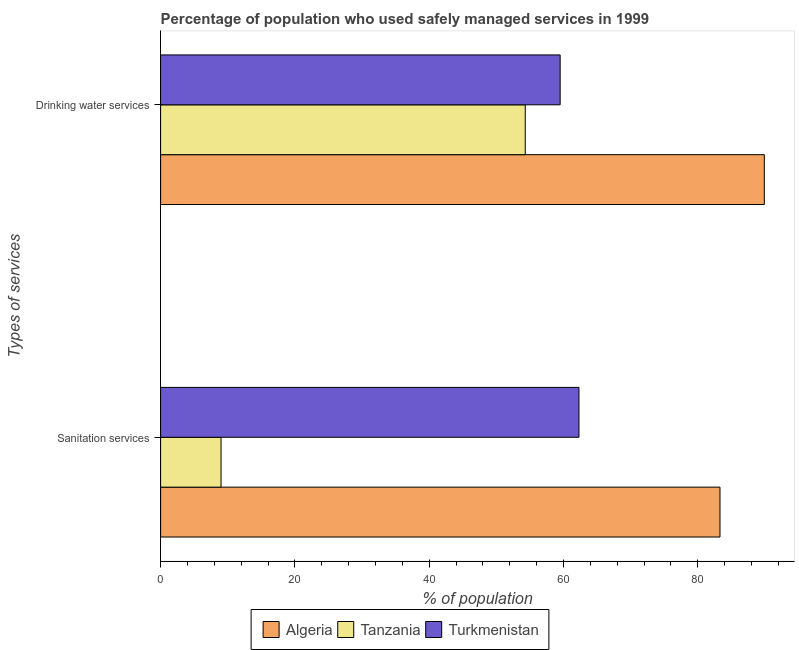How many different coloured bars are there?
Provide a short and direct response. 3. Are the number of bars per tick equal to the number of legend labels?
Offer a terse response. Yes. How many bars are there on the 2nd tick from the bottom?
Keep it short and to the point. 3. What is the label of the 1st group of bars from the top?
Provide a succinct answer. Drinking water services. What is the percentage of population who used sanitation services in Turkmenistan?
Provide a short and direct response. 62.3. Across all countries, what is the maximum percentage of population who used sanitation services?
Keep it short and to the point. 83.3. In which country was the percentage of population who used drinking water services maximum?
Give a very brief answer. Algeria. In which country was the percentage of population who used drinking water services minimum?
Your answer should be very brief. Tanzania. What is the total percentage of population who used sanitation services in the graph?
Your answer should be very brief. 154.6. What is the difference between the percentage of population who used sanitation services in Tanzania and that in Turkmenistan?
Your answer should be very brief. -53.3. What is the difference between the percentage of population who used drinking water services in Turkmenistan and the percentage of population who used sanitation services in Algeria?
Offer a terse response. -23.8. What is the average percentage of population who used sanitation services per country?
Keep it short and to the point. 51.53. What is the difference between the percentage of population who used sanitation services and percentage of population who used drinking water services in Turkmenistan?
Give a very brief answer. 2.8. In how many countries, is the percentage of population who used drinking water services greater than 84 %?
Ensure brevity in your answer.  1. What is the ratio of the percentage of population who used sanitation services in Turkmenistan to that in Tanzania?
Provide a short and direct response. 6.92. In how many countries, is the percentage of population who used drinking water services greater than the average percentage of population who used drinking water services taken over all countries?
Provide a succinct answer. 1. What does the 1st bar from the top in Sanitation services represents?
Ensure brevity in your answer.  Turkmenistan. What does the 1st bar from the bottom in Drinking water services represents?
Make the answer very short. Algeria. Are all the bars in the graph horizontal?
Offer a very short reply. Yes. Does the graph contain any zero values?
Your answer should be very brief. No. What is the title of the graph?
Your answer should be compact. Percentage of population who used safely managed services in 1999. Does "Sub-Saharan Africa (developing only)" appear as one of the legend labels in the graph?
Make the answer very short. No. What is the label or title of the X-axis?
Provide a succinct answer. % of population. What is the label or title of the Y-axis?
Your answer should be compact. Types of services. What is the % of population in Algeria in Sanitation services?
Offer a terse response. 83.3. What is the % of population of Tanzania in Sanitation services?
Provide a short and direct response. 9. What is the % of population of Turkmenistan in Sanitation services?
Give a very brief answer. 62.3. What is the % of population of Algeria in Drinking water services?
Your response must be concise. 89.9. What is the % of population in Tanzania in Drinking water services?
Give a very brief answer. 54.3. What is the % of population in Turkmenistan in Drinking water services?
Your answer should be very brief. 59.5. Across all Types of services, what is the maximum % of population in Algeria?
Offer a very short reply. 89.9. Across all Types of services, what is the maximum % of population in Tanzania?
Your answer should be compact. 54.3. Across all Types of services, what is the maximum % of population of Turkmenistan?
Give a very brief answer. 62.3. Across all Types of services, what is the minimum % of population of Algeria?
Give a very brief answer. 83.3. Across all Types of services, what is the minimum % of population of Tanzania?
Give a very brief answer. 9. Across all Types of services, what is the minimum % of population in Turkmenistan?
Offer a terse response. 59.5. What is the total % of population of Algeria in the graph?
Provide a succinct answer. 173.2. What is the total % of population in Tanzania in the graph?
Provide a short and direct response. 63.3. What is the total % of population of Turkmenistan in the graph?
Offer a terse response. 121.8. What is the difference between the % of population in Algeria in Sanitation services and that in Drinking water services?
Your response must be concise. -6.6. What is the difference between the % of population of Tanzania in Sanitation services and that in Drinking water services?
Your answer should be compact. -45.3. What is the difference between the % of population of Algeria in Sanitation services and the % of population of Tanzania in Drinking water services?
Offer a terse response. 29. What is the difference between the % of population in Algeria in Sanitation services and the % of population in Turkmenistan in Drinking water services?
Offer a terse response. 23.8. What is the difference between the % of population of Tanzania in Sanitation services and the % of population of Turkmenistan in Drinking water services?
Give a very brief answer. -50.5. What is the average % of population of Algeria per Types of services?
Offer a terse response. 86.6. What is the average % of population in Tanzania per Types of services?
Keep it short and to the point. 31.65. What is the average % of population in Turkmenistan per Types of services?
Provide a short and direct response. 60.9. What is the difference between the % of population of Algeria and % of population of Tanzania in Sanitation services?
Give a very brief answer. 74.3. What is the difference between the % of population of Tanzania and % of population of Turkmenistan in Sanitation services?
Provide a succinct answer. -53.3. What is the difference between the % of population in Algeria and % of population in Tanzania in Drinking water services?
Give a very brief answer. 35.6. What is the difference between the % of population of Algeria and % of population of Turkmenistan in Drinking water services?
Provide a short and direct response. 30.4. What is the ratio of the % of population in Algeria in Sanitation services to that in Drinking water services?
Your response must be concise. 0.93. What is the ratio of the % of population in Tanzania in Sanitation services to that in Drinking water services?
Your answer should be compact. 0.17. What is the ratio of the % of population of Turkmenistan in Sanitation services to that in Drinking water services?
Keep it short and to the point. 1.05. What is the difference between the highest and the second highest % of population in Algeria?
Offer a terse response. 6.6. What is the difference between the highest and the second highest % of population of Tanzania?
Ensure brevity in your answer.  45.3. What is the difference between the highest and the lowest % of population of Algeria?
Offer a terse response. 6.6. What is the difference between the highest and the lowest % of population of Tanzania?
Keep it short and to the point. 45.3. What is the difference between the highest and the lowest % of population of Turkmenistan?
Keep it short and to the point. 2.8. 